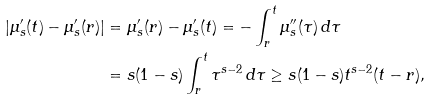<formula> <loc_0><loc_0><loc_500><loc_500>| \mu _ { s } ^ { \prime } ( t ) - \mu _ { s } ^ { \prime } ( r ) | & = \mu _ { s } ^ { \prime } ( r ) - \mu _ { s } ^ { \prime } ( t ) = - \int _ { r } ^ { t } \mu _ { s } ^ { \prime \prime } ( \tau ) \, d \tau \\ & = s ( 1 - s ) \int _ { r } ^ { t } \tau ^ { s - 2 } \, d \tau \geq s ( 1 - s ) t ^ { s - 2 } ( t - r ) ,</formula> 